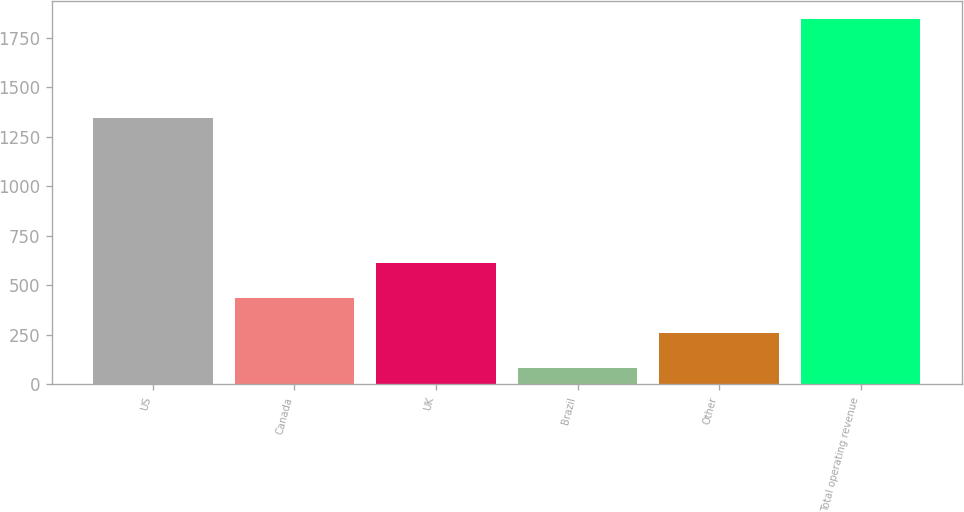Convert chart. <chart><loc_0><loc_0><loc_500><loc_500><bar_chart><fcel>US<fcel>Canada<fcel>UK<fcel>Brazil<fcel>Other<fcel>Total operating revenue<nl><fcel>1344.5<fcel>435<fcel>611<fcel>83<fcel>259<fcel>1843<nl></chart> 